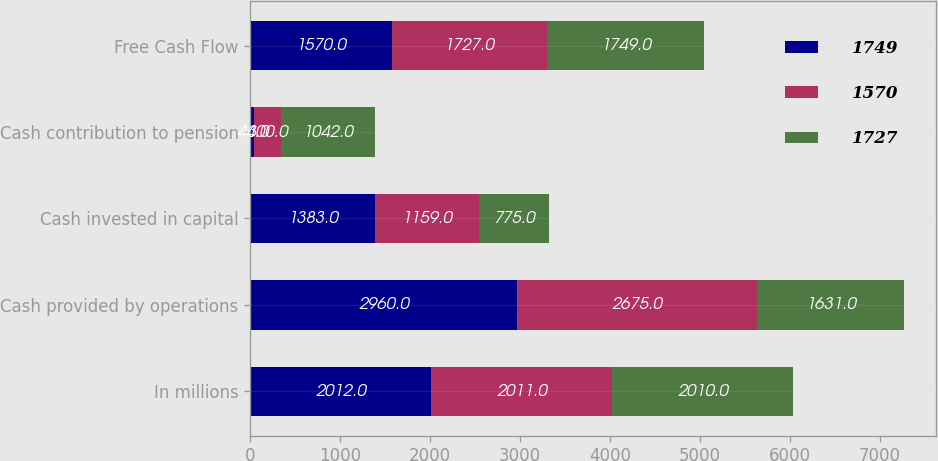Convert chart to OTSL. <chart><loc_0><loc_0><loc_500><loc_500><stacked_bar_chart><ecel><fcel>In millions<fcel>Cash provided by operations<fcel>Cash invested in capital<fcel>Cash contribution to pension<fcel>Free Cash Flow<nl><fcel>1749<fcel>2012<fcel>2960<fcel>1383<fcel>44<fcel>1570<nl><fcel>1570<fcel>2011<fcel>2675<fcel>1159<fcel>300<fcel>1727<nl><fcel>1727<fcel>2010<fcel>1631<fcel>775<fcel>1042<fcel>1749<nl></chart> 